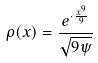Convert formula to latex. <formula><loc_0><loc_0><loc_500><loc_500>\rho ( x ) = \frac { e ^ { \cdot \frac { x ^ { 9 } } { 9 } } } { \sqrt { 9 \psi } }</formula> 